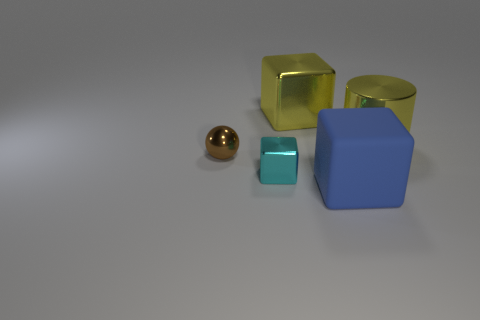Is there any pattern in the arrangement of the objects? The objects are arranged with no specific pattern; they are placed randomly with varying distances and orientations on a flat surface. 